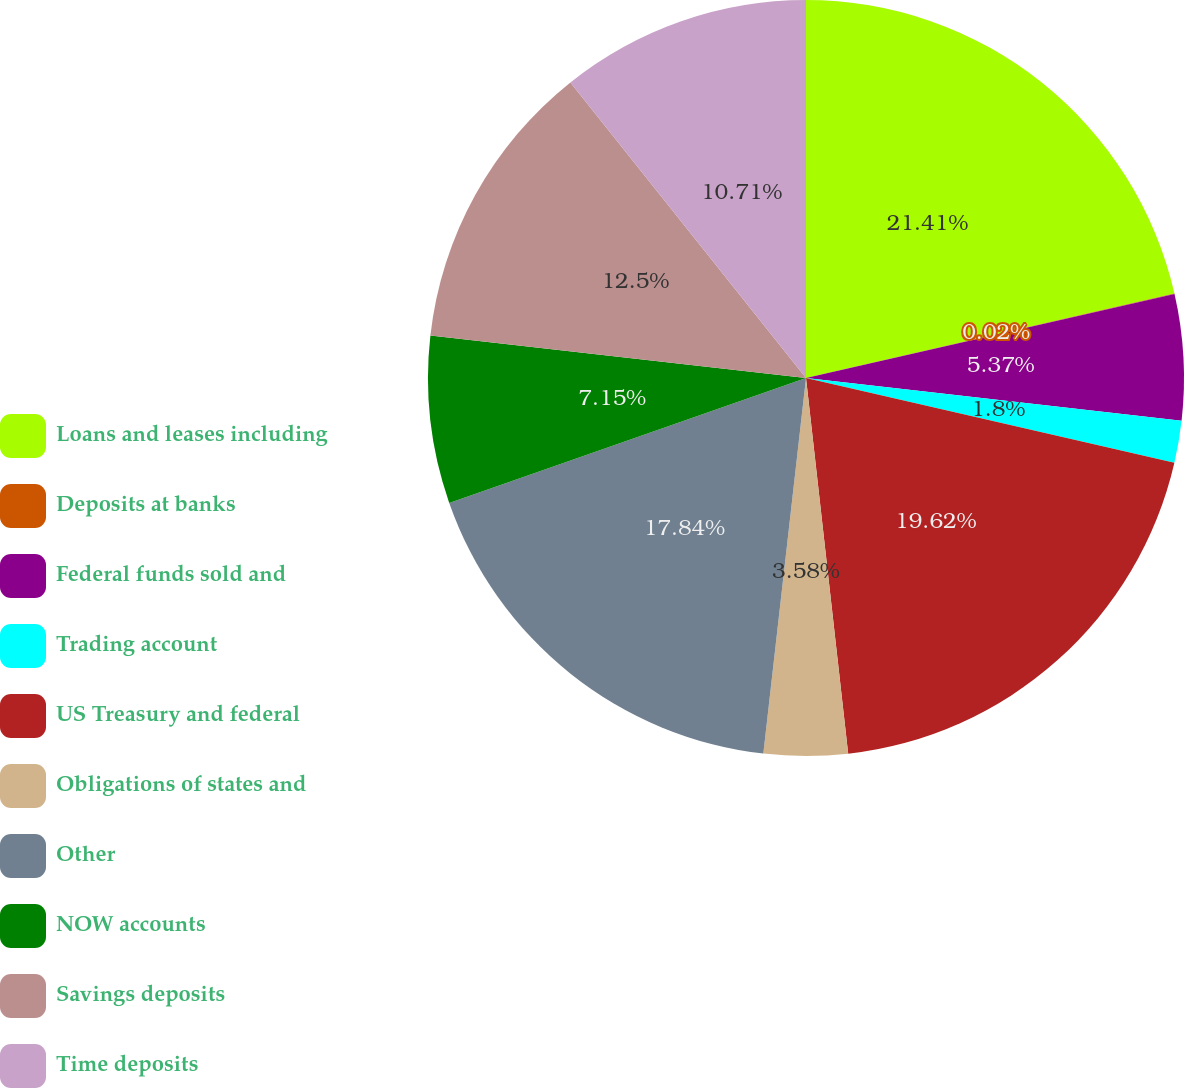Convert chart to OTSL. <chart><loc_0><loc_0><loc_500><loc_500><pie_chart><fcel>Loans and leases including<fcel>Deposits at banks<fcel>Federal funds sold and<fcel>Trading account<fcel>US Treasury and federal<fcel>Obligations of states and<fcel>Other<fcel>NOW accounts<fcel>Savings deposits<fcel>Time deposits<nl><fcel>21.41%<fcel>0.02%<fcel>5.37%<fcel>1.8%<fcel>19.62%<fcel>3.58%<fcel>17.84%<fcel>7.15%<fcel>12.5%<fcel>10.71%<nl></chart> 